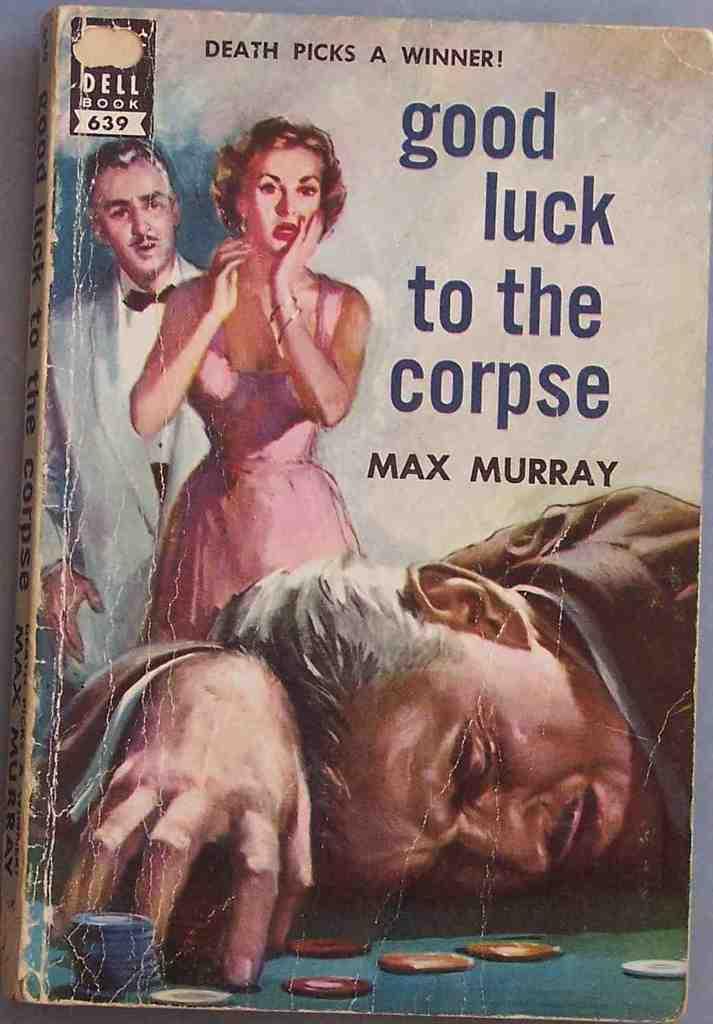What is the name of this book?
Your answer should be compact. Good luck to the corpse. Who wrote this book?
Ensure brevity in your answer.  Max murray. 